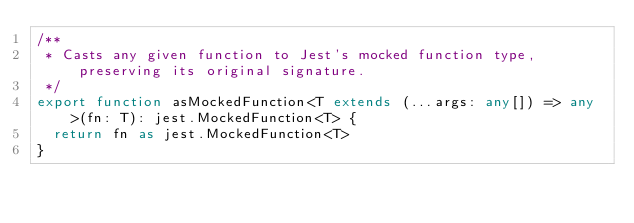Convert code to text. <code><loc_0><loc_0><loc_500><loc_500><_TypeScript_>/**
 * Casts any given function to Jest's mocked function type, preserving its original signature.
 */
export function asMockedFunction<T extends (...args: any[]) => any>(fn: T): jest.MockedFunction<T> {
  return fn as jest.MockedFunction<T>
}
</code> 